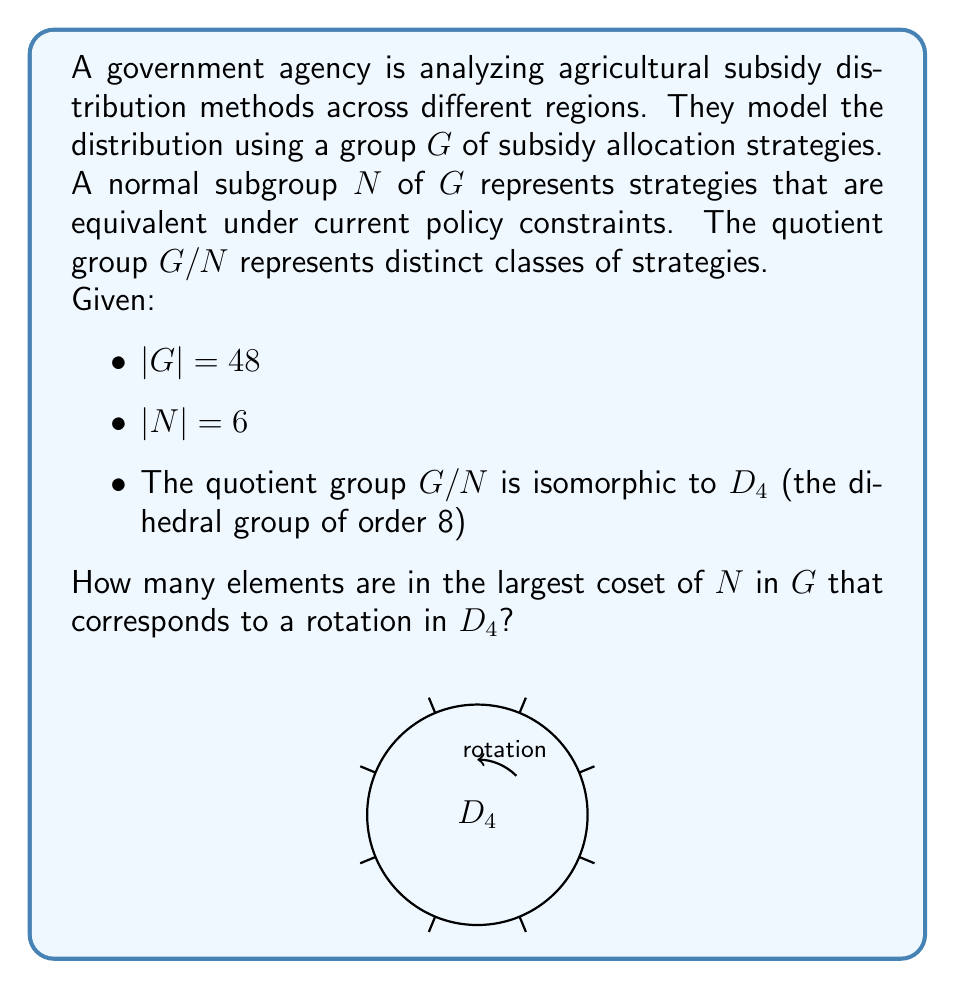Provide a solution to this math problem. Let's approach this step-by-step:

1) First, recall the Lagrange's theorem: for a subgroup $H$ of a finite group $G$, $|G| = |H| \cdot [G:H]$, where $[G:H]$ is the index of $H$ in $G$.

2) We're given that $|G| = 48$ and $|N| = 6$. Let's calculate the order of $G/N$:

   $|G/N| = \frac{|G|}{|N|} = \frac{48}{6} = 8$

3) This matches with the information that $G/N$ is isomorphic to $D_4$, which has order 8.

4) In $D_4$, there are:
   - 1 identity element
   - 3 rotations (by 90°, 180°, and 270°)
   - 4 reflections

5) Each element of $G/N$ corresponds to a coset of $N$ in $G$. All cosets of $N$ in $G$ have the same size as $N$, which is 6.

6) The rotations in $D_4$ (including the identity) form a cyclic subgroup of order 4. Each of these 4 elements (in $G/N$) corresponds to a coset of $N$ in $G$ with 6 elements.

Therefore, the largest coset of $N$ in $G$ that corresponds to a rotation in $D_4$ has 6 elements.
Answer: 6 